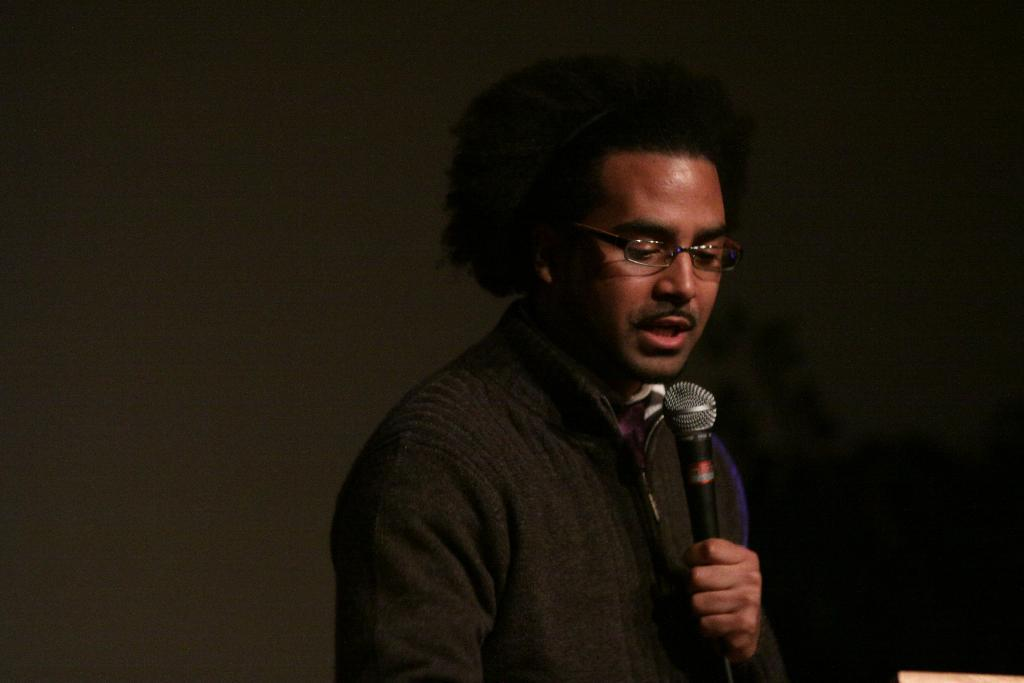What is the main subject of the image? There is a person in the image. What is the person holding in the image? The person is holding a microphone. What color jacket is the person wearing? The person is wearing a black color jacket. How would you describe the background of the image? The background of the image is dark. How many clocks can be seen in the image? There are no clocks visible in the image. What type of clouds are present in the image? There are no clouds present in the image. 